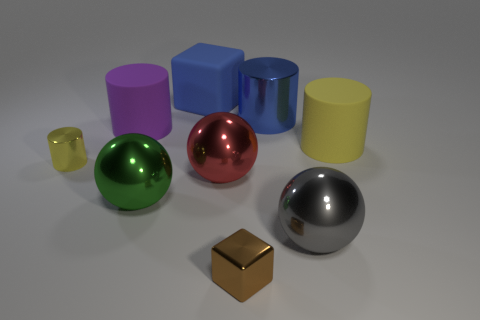Do the big blue object that is behind the blue cylinder and the brown object have the same shape?
Ensure brevity in your answer.  Yes. What color is the block that is the same material as the green thing?
Provide a short and direct response. Brown. What is the material of the yellow cylinder that is on the right side of the blue matte object?
Give a very brief answer. Rubber. Does the brown metallic object have the same shape as the blue thing on the left side of the tiny brown shiny block?
Give a very brief answer. Yes. There is a object that is both in front of the large yellow rubber thing and left of the big green thing; what is its material?
Your answer should be very brief. Metal. The metal cylinder that is the same size as the purple rubber object is what color?
Provide a short and direct response. Blue. Are the large yellow object and the cylinder behind the purple cylinder made of the same material?
Offer a terse response. No. What number of other things are there of the same size as the red shiny thing?
Your answer should be very brief. 6. Is there a cylinder that is to the right of the matte cylinder right of the block that is in front of the big green object?
Provide a succinct answer. No. The red thing has what size?
Your answer should be very brief. Large. 